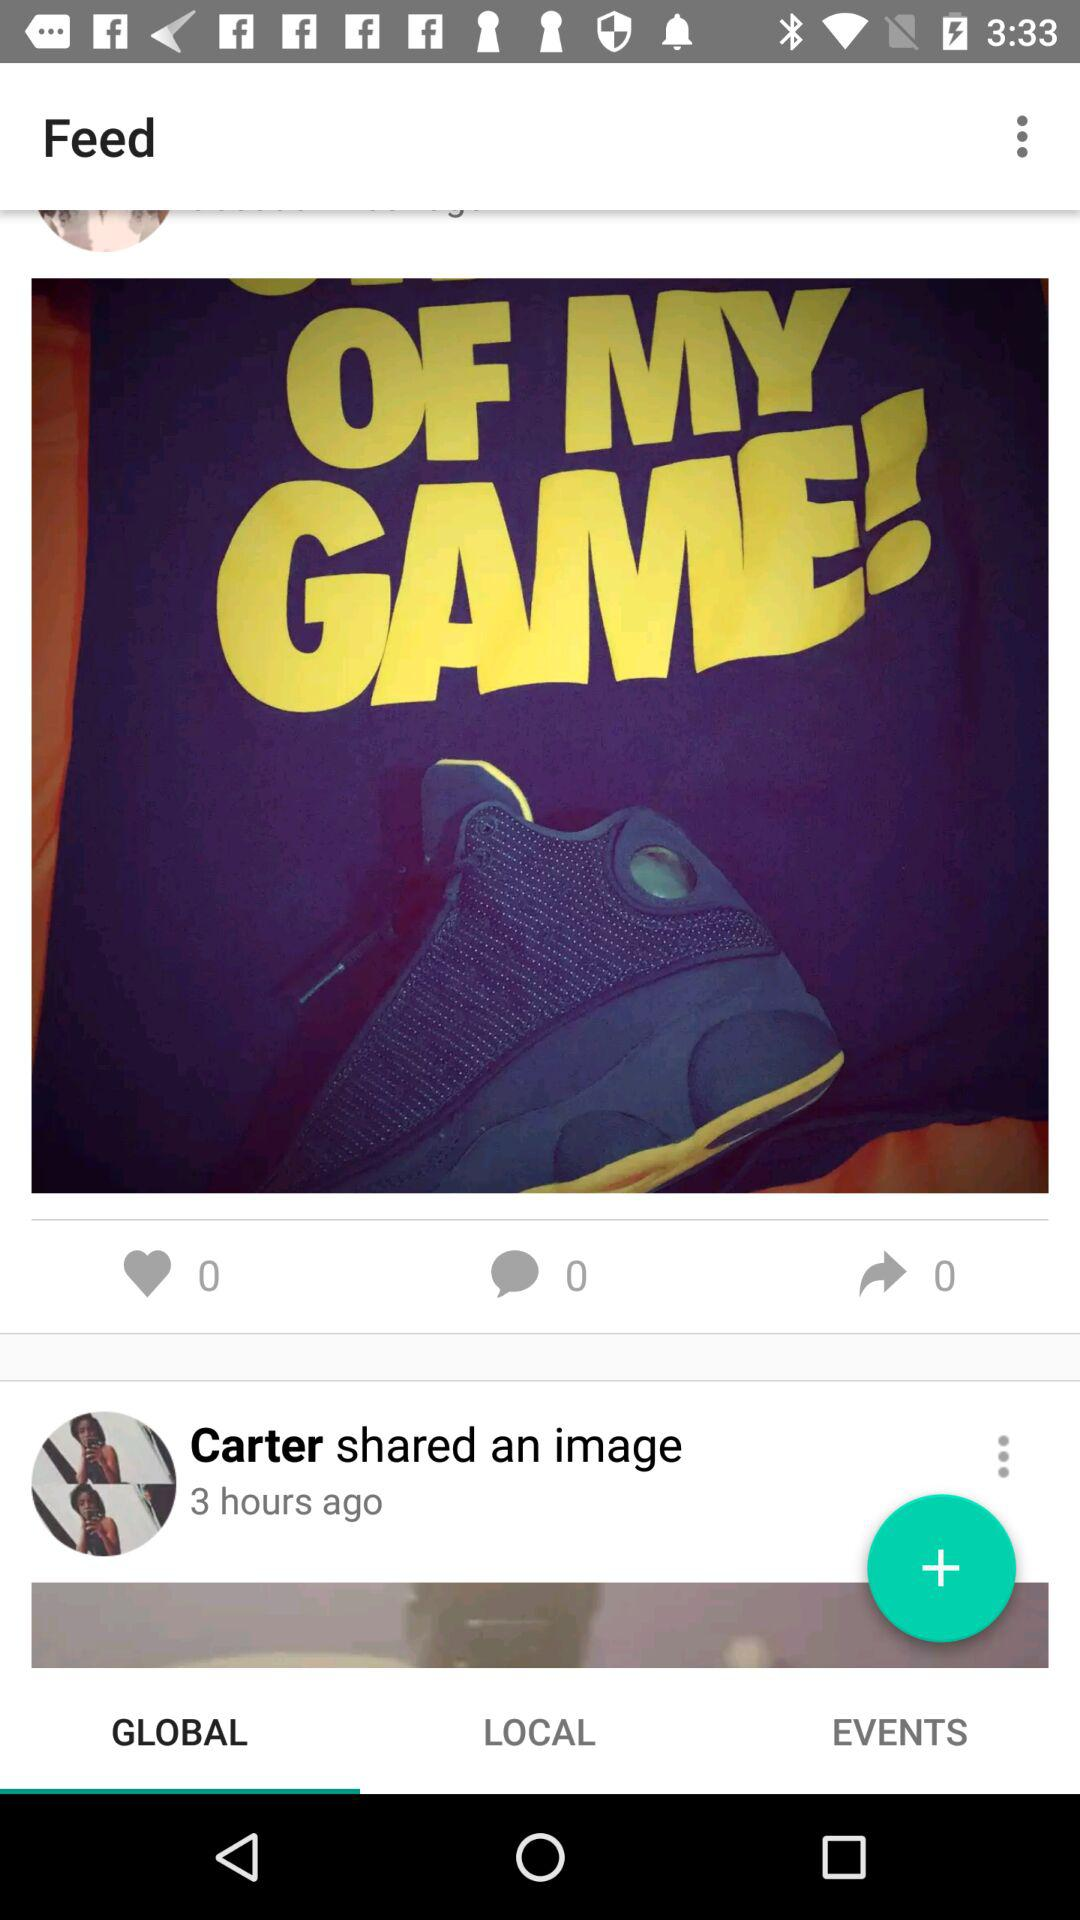What is the user profile name? The user profile name is Carter. 